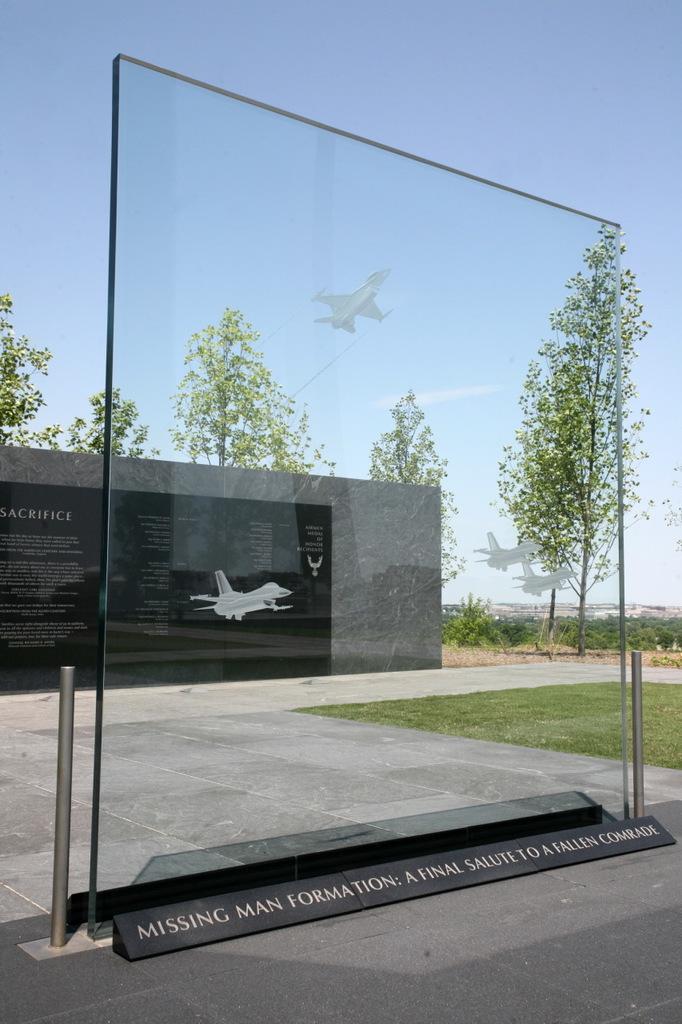Can you describe this image briefly? In this image in the foreground there is a glass board, and some rods and board. In the background there is wall and some text, at the bottom there is a walkway and grass, and in the background there are airplanes and trees, plants, sand. At the top there is sky. 